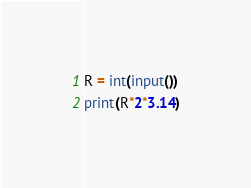Convert code to text. <code><loc_0><loc_0><loc_500><loc_500><_Python_>R = int(input())
print(R*2*3.14)</code> 